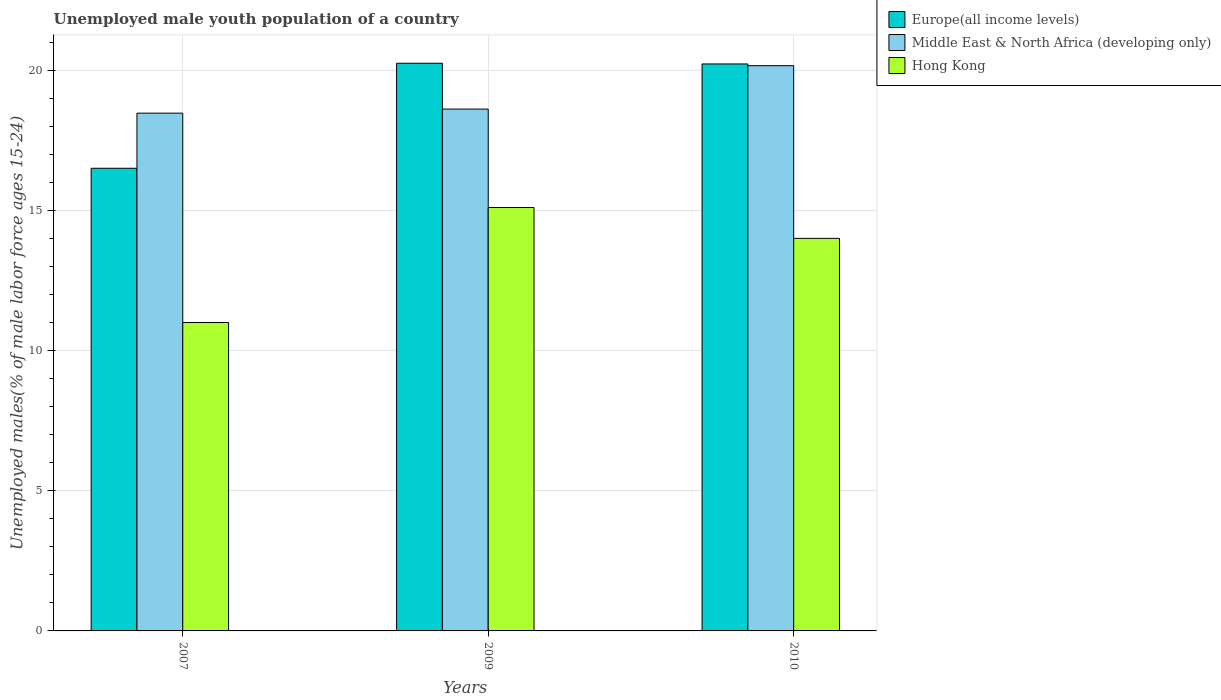How many different coloured bars are there?
Your response must be concise. 3. How many bars are there on the 1st tick from the left?
Keep it short and to the point. 3. What is the label of the 2nd group of bars from the left?
Make the answer very short. 2009. What is the percentage of unemployed male youth population in Europe(all income levels) in 2007?
Make the answer very short. 16.5. Across all years, what is the maximum percentage of unemployed male youth population in Europe(all income levels)?
Your response must be concise. 20.25. Across all years, what is the minimum percentage of unemployed male youth population in Europe(all income levels)?
Offer a very short reply. 16.5. In which year was the percentage of unemployed male youth population in Middle East & North Africa (developing only) minimum?
Provide a succinct answer. 2007. What is the total percentage of unemployed male youth population in Hong Kong in the graph?
Give a very brief answer. 40.1. What is the difference between the percentage of unemployed male youth population in Europe(all income levels) in 2007 and that in 2009?
Offer a very short reply. -3.75. What is the difference between the percentage of unemployed male youth population in Middle East & North Africa (developing only) in 2007 and the percentage of unemployed male youth population in Hong Kong in 2010?
Provide a succinct answer. 4.47. What is the average percentage of unemployed male youth population in Hong Kong per year?
Offer a terse response. 13.37. In the year 2009, what is the difference between the percentage of unemployed male youth population in Hong Kong and percentage of unemployed male youth population in Middle East & North Africa (developing only)?
Your response must be concise. -3.51. In how many years, is the percentage of unemployed male youth population in Hong Kong greater than 18 %?
Your answer should be compact. 0. What is the ratio of the percentage of unemployed male youth population in Europe(all income levels) in 2009 to that in 2010?
Make the answer very short. 1. What is the difference between the highest and the second highest percentage of unemployed male youth population in Hong Kong?
Offer a terse response. 1.1. What is the difference between the highest and the lowest percentage of unemployed male youth population in Europe(all income levels)?
Your response must be concise. 3.75. In how many years, is the percentage of unemployed male youth population in Hong Kong greater than the average percentage of unemployed male youth population in Hong Kong taken over all years?
Your response must be concise. 2. Is the sum of the percentage of unemployed male youth population in Hong Kong in 2007 and 2009 greater than the maximum percentage of unemployed male youth population in Europe(all income levels) across all years?
Give a very brief answer. Yes. What does the 2nd bar from the left in 2010 represents?
Ensure brevity in your answer.  Middle East & North Africa (developing only). What does the 3rd bar from the right in 2010 represents?
Ensure brevity in your answer.  Europe(all income levels). Are all the bars in the graph horizontal?
Your answer should be compact. No. Does the graph contain any zero values?
Give a very brief answer. No. Does the graph contain grids?
Offer a terse response. Yes. How are the legend labels stacked?
Your answer should be compact. Vertical. What is the title of the graph?
Provide a short and direct response. Unemployed male youth population of a country. What is the label or title of the X-axis?
Keep it short and to the point. Years. What is the label or title of the Y-axis?
Provide a short and direct response. Unemployed males(% of male labor force ages 15-24). What is the Unemployed males(% of male labor force ages 15-24) of Europe(all income levels) in 2007?
Provide a succinct answer. 16.5. What is the Unemployed males(% of male labor force ages 15-24) in Middle East & North Africa (developing only) in 2007?
Your response must be concise. 18.47. What is the Unemployed males(% of male labor force ages 15-24) of Hong Kong in 2007?
Ensure brevity in your answer.  11. What is the Unemployed males(% of male labor force ages 15-24) in Europe(all income levels) in 2009?
Provide a succinct answer. 20.25. What is the Unemployed males(% of male labor force ages 15-24) of Middle East & North Africa (developing only) in 2009?
Offer a terse response. 18.61. What is the Unemployed males(% of male labor force ages 15-24) of Hong Kong in 2009?
Ensure brevity in your answer.  15.1. What is the Unemployed males(% of male labor force ages 15-24) of Europe(all income levels) in 2010?
Keep it short and to the point. 20.22. What is the Unemployed males(% of male labor force ages 15-24) in Middle East & North Africa (developing only) in 2010?
Provide a succinct answer. 20.16. What is the Unemployed males(% of male labor force ages 15-24) of Hong Kong in 2010?
Ensure brevity in your answer.  14. Across all years, what is the maximum Unemployed males(% of male labor force ages 15-24) of Europe(all income levels)?
Ensure brevity in your answer.  20.25. Across all years, what is the maximum Unemployed males(% of male labor force ages 15-24) of Middle East & North Africa (developing only)?
Your answer should be compact. 20.16. Across all years, what is the maximum Unemployed males(% of male labor force ages 15-24) of Hong Kong?
Provide a succinct answer. 15.1. Across all years, what is the minimum Unemployed males(% of male labor force ages 15-24) of Europe(all income levels)?
Keep it short and to the point. 16.5. Across all years, what is the minimum Unemployed males(% of male labor force ages 15-24) of Middle East & North Africa (developing only)?
Ensure brevity in your answer.  18.47. What is the total Unemployed males(% of male labor force ages 15-24) in Europe(all income levels) in the graph?
Your answer should be compact. 56.97. What is the total Unemployed males(% of male labor force ages 15-24) in Middle East & North Africa (developing only) in the graph?
Ensure brevity in your answer.  57.24. What is the total Unemployed males(% of male labor force ages 15-24) in Hong Kong in the graph?
Ensure brevity in your answer.  40.1. What is the difference between the Unemployed males(% of male labor force ages 15-24) in Europe(all income levels) in 2007 and that in 2009?
Your answer should be compact. -3.75. What is the difference between the Unemployed males(% of male labor force ages 15-24) in Middle East & North Africa (developing only) in 2007 and that in 2009?
Offer a terse response. -0.15. What is the difference between the Unemployed males(% of male labor force ages 15-24) of Hong Kong in 2007 and that in 2009?
Your answer should be very brief. -4.1. What is the difference between the Unemployed males(% of male labor force ages 15-24) of Europe(all income levels) in 2007 and that in 2010?
Your response must be concise. -3.72. What is the difference between the Unemployed males(% of male labor force ages 15-24) in Middle East & North Africa (developing only) in 2007 and that in 2010?
Offer a very short reply. -1.69. What is the difference between the Unemployed males(% of male labor force ages 15-24) of Hong Kong in 2007 and that in 2010?
Your answer should be very brief. -3. What is the difference between the Unemployed males(% of male labor force ages 15-24) in Europe(all income levels) in 2009 and that in 2010?
Make the answer very short. 0.02. What is the difference between the Unemployed males(% of male labor force ages 15-24) in Middle East & North Africa (developing only) in 2009 and that in 2010?
Make the answer very short. -1.55. What is the difference between the Unemployed males(% of male labor force ages 15-24) of Hong Kong in 2009 and that in 2010?
Your answer should be very brief. 1.1. What is the difference between the Unemployed males(% of male labor force ages 15-24) of Europe(all income levels) in 2007 and the Unemployed males(% of male labor force ages 15-24) of Middle East & North Africa (developing only) in 2009?
Give a very brief answer. -2.11. What is the difference between the Unemployed males(% of male labor force ages 15-24) of Europe(all income levels) in 2007 and the Unemployed males(% of male labor force ages 15-24) of Hong Kong in 2009?
Offer a terse response. 1.4. What is the difference between the Unemployed males(% of male labor force ages 15-24) of Middle East & North Africa (developing only) in 2007 and the Unemployed males(% of male labor force ages 15-24) of Hong Kong in 2009?
Your answer should be very brief. 3.37. What is the difference between the Unemployed males(% of male labor force ages 15-24) in Europe(all income levels) in 2007 and the Unemployed males(% of male labor force ages 15-24) in Middle East & North Africa (developing only) in 2010?
Your answer should be compact. -3.66. What is the difference between the Unemployed males(% of male labor force ages 15-24) in Europe(all income levels) in 2007 and the Unemployed males(% of male labor force ages 15-24) in Hong Kong in 2010?
Ensure brevity in your answer.  2.5. What is the difference between the Unemployed males(% of male labor force ages 15-24) in Middle East & North Africa (developing only) in 2007 and the Unemployed males(% of male labor force ages 15-24) in Hong Kong in 2010?
Your answer should be very brief. 4.47. What is the difference between the Unemployed males(% of male labor force ages 15-24) of Europe(all income levels) in 2009 and the Unemployed males(% of male labor force ages 15-24) of Middle East & North Africa (developing only) in 2010?
Your response must be concise. 0.09. What is the difference between the Unemployed males(% of male labor force ages 15-24) in Europe(all income levels) in 2009 and the Unemployed males(% of male labor force ages 15-24) in Hong Kong in 2010?
Ensure brevity in your answer.  6.25. What is the difference between the Unemployed males(% of male labor force ages 15-24) in Middle East & North Africa (developing only) in 2009 and the Unemployed males(% of male labor force ages 15-24) in Hong Kong in 2010?
Your answer should be compact. 4.61. What is the average Unemployed males(% of male labor force ages 15-24) in Europe(all income levels) per year?
Ensure brevity in your answer.  18.99. What is the average Unemployed males(% of male labor force ages 15-24) of Middle East & North Africa (developing only) per year?
Provide a short and direct response. 19.08. What is the average Unemployed males(% of male labor force ages 15-24) in Hong Kong per year?
Keep it short and to the point. 13.37. In the year 2007, what is the difference between the Unemployed males(% of male labor force ages 15-24) of Europe(all income levels) and Unemployed males(% of male labor force ages 15-24) of Middle East & North Africa (developing only)?
Keep it short and to the point. -1.97. In the year 2007, what is the difference between the Unemployed males(% of male labor force ages 15-24) of Europe(all income levels) and Unemployed males(% of male labor force ages 15-24) of Hong Kong?
Make the answer very short. 5.5. In the year 2007, what is the difference between the Unemployed males(% of male labor force ages 15-24) of Middle East & North Africa (developing only) and Unemployed males(% of male labor force ages 15-24) of Hong Kong?
Make the answer very short. 7.47. In the year 2009, what is the difference between the Unemployed males(% of male labor force ages 15-24) in Europe(all income levels) and Unemployed males(% of male labor force ages 15-24) in Middle East & North Africa (developing only)?
Make the answer very short. 1.63. In the year 2009, what is the difference between the Unemployed males(% of male labor force ages 15-24) of Europe(all income levels) and Unemployed males(% of male labor force ages 15-24) of Hong Kong?
Offer a terse response. 5.15. In the year 2009, what is the difference between the Unemployed males(% of male labor force ages 15-24) of Middle East & North Africa (developing only) and Unemployed males(% of male labor force ages 15-24) of Hong Kong?
Provide a short and direct response. 3.51. In the year 2010, what is the difference between the Unemployed males(% of male labor force ages 15-24) of Europe(all income levels) and Unemployed males(% of male labor force ages 15-24) of Middle East & North Africa (developing only)?
Provide a short and direct response. 0.06. In the year 2010, what is the difference between the Unemployed males(% of male labor force ages 15-24) in Europe(all income levels) and Unemployed males(% of male labor force ages 15-24) in Hong Kong?
Keep it short and to the point. 6.22. In the year 2010, what is the difference between the Unemployed males(% of male labor force ages 15-24) of Middle East & North Africa (developing only) and Unemployed males(% of male labor force ages 15-24) of Hong Kong?
Make the answer very short. 6.16. What is the ratio of the Unemployed males(% of male labor force ages 15-24) in Europe(all income levels) in 2007 to that in 2009?
Offer a terse response. 0.81. What is the ratio of the Unemployed males(% of male labor force ages 15-24) of Middle East & North Africa (developing only) in 2007 to that in 2009?
Offer a very short reply. 0.99. What is the ratio of the Unemployed males(% of male labor force ages 15-24) of Hong Kong in 2007 to that in 2009?
Offer a very short reply. 0.73. What is the ratio of the Unemployed males(% of male labor force ages 15-24) of Europe(all income levels) in 2007 to that in 2010?
Provide a succinct answer. 0.82. What is the ratio of the Unemployed males(% of male labor force ages 15-24) of Middle East & North Africa (developing only) in 2007 to that in 2010?
Ensure brevity in your answer.  0.92. What is the ratio of the Unemployed males(% of male labor force ages 15-24) in Hong Kong in 2007 to that in 2010?
Offer a very short reply. 0.79. What is the ratio of the Unemployed males(% of male labor force ages 15-24) of Middle East & North Africa (developing only) in 2009 to that in 2010?
Make the answer very short. 0.92. What is the ratio of the Unemployed males(% of male labor force ages 15-24) in Hong Kong in 2009 to that in 2010?
Your answer should be very brief. 1.08. What is the difference between the highest and the second highest Unemployed males(% of male labor force ages 15-24) in Europe(all income levels)?
Ensure brevity in your answer.  0.02. What is the difference between the highest and the second highest Unemployed males(% of male labor force ages 15-24) of Middle East & North Africa (developing only)?
Your answer should be very brief. 1.55. What is the difference between the highest and the lowest Unemployed males(% of male labor force ages 15-24) of Europe(all income levels)?
Your answer should be very brief. 3.75. What is the difference between the highest and the lowest Unemployed males(% of male labor force ages 15-24) of Middle East & North Africa (developing only)?
Keep it short and to the point. 1.69. 